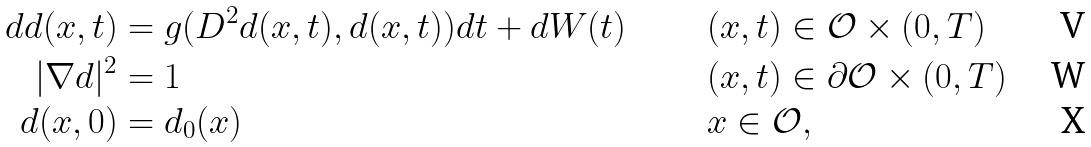Convert formula to latex. <formula><loc_0><loc_0><loc_500><loc_500>d d ( x , t ) & = g ( D ^ { 2 } d ( x , t ) , d ( x , t ) ) d t + d W ( t ) \quad & & ( x , t ) \in \mathcal { O } \times ( 0 , T ) \\ | \nabla d | ^ { 2 } & = 1 \quad & & ( x , t ) \in \partial \mathcal { O } \times ( 0 , T ) \\ d ( x , 0 ) & = d _ { 0 } ( x ) \quad & & x \in \mathcal { O } ,</formula> 